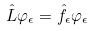Convert formula to latex. <formula><loc_0><loc_0><loc_500><loc_500>\hat { L } \varphi _ { \epsilon } = \hat { f } _ { \epsilon } \varphi _ { \epsilon }</formula> 